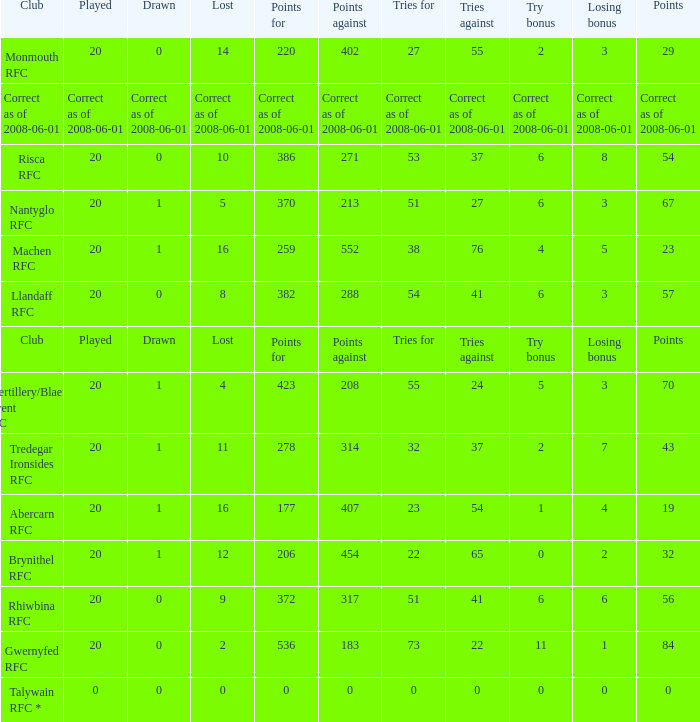If the points were 0, what was the losing bonus? 0.0. 